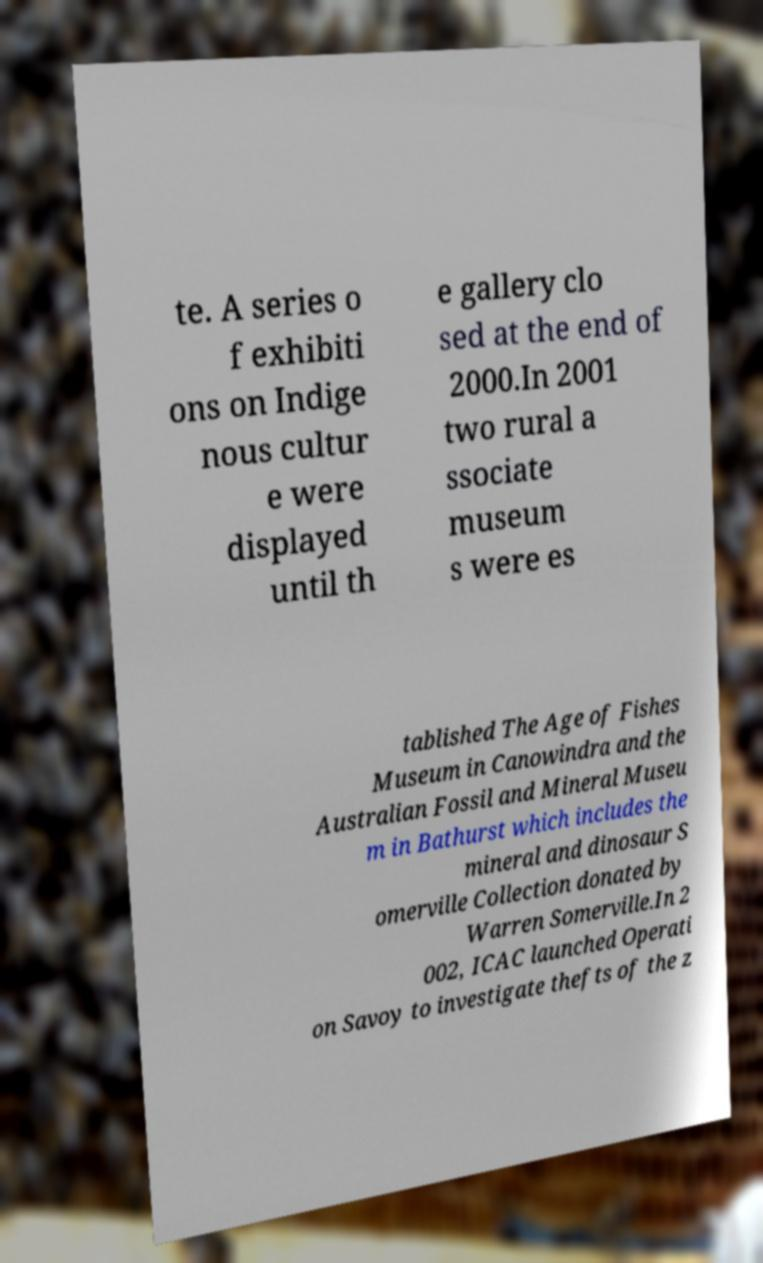Could you assist in decoding the text presented in this image and type it out clearly? te. A series o f exhibiti ons on Indige nous cultur e were displayed until th e gallery clo sed at the end of 2000.In 2001 two rural a ssociate museum s were es tablished The Age of Fishes Museum in Canowindra and the Australian Fossil and Mineral Museu m in Bathurst which includes the mineral and dinosaur S omerville Collection donated by Warren Somerville.In 2 002, ICAC launched Operati on Savoy to investigate thefts of the z 